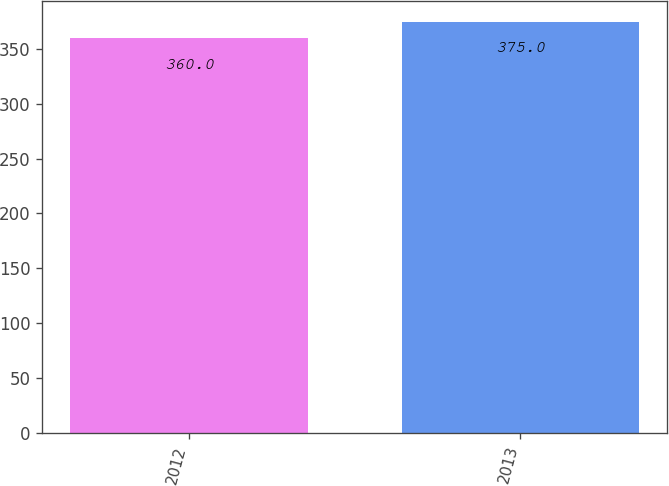<chart> <loc_0><loc_0><loc_500><loc_500><bar_chart><fcel>2012<fcel>2013<nl><fcel>360<fcel>375<nl></chart> 